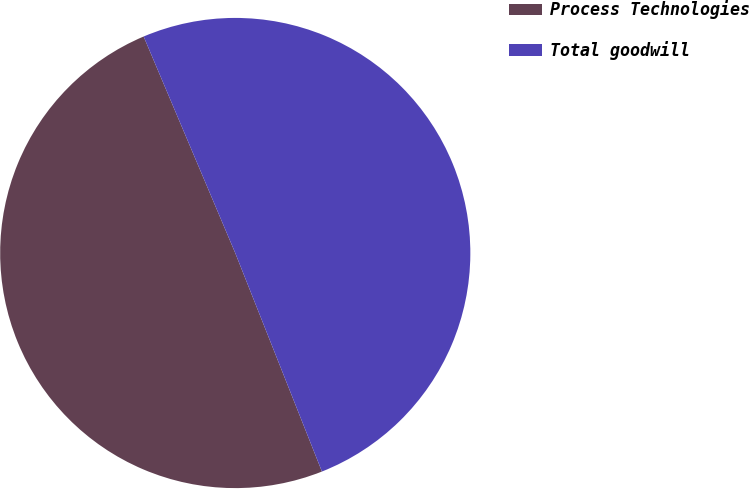Convert chart. <chart><loc_0><loc_0><loc_500><loc_500><pie_chart><fcel>Process Technologies<fcel>Total goodwill<nl><fcel>49.64%<fcel>50.36%<nl></chart> 